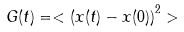<formula> <loc_0><loc_0><loc_500><loc_500>G ( t ) = < \left ( x ( t ) - x ( 0 ) \right ) ^ { 2 } ></formula> 